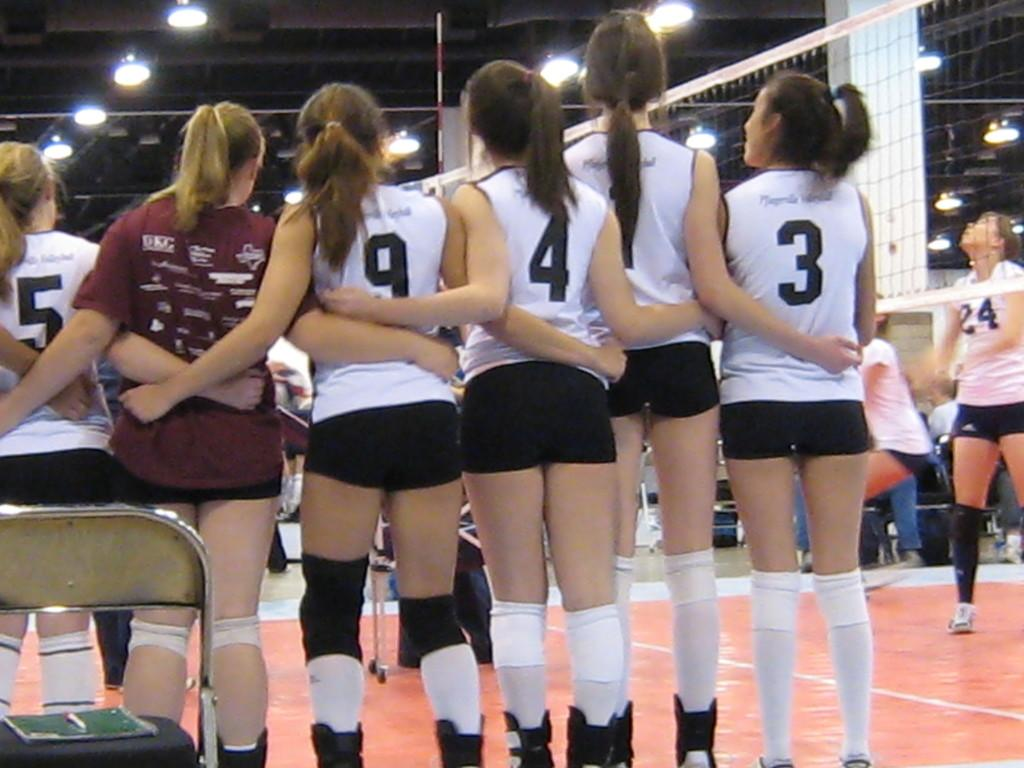<image>
Offer a succinct explanation of the picture presented. Female athletes wear shirts with 5, 9, 4 and 3 on the backs. 